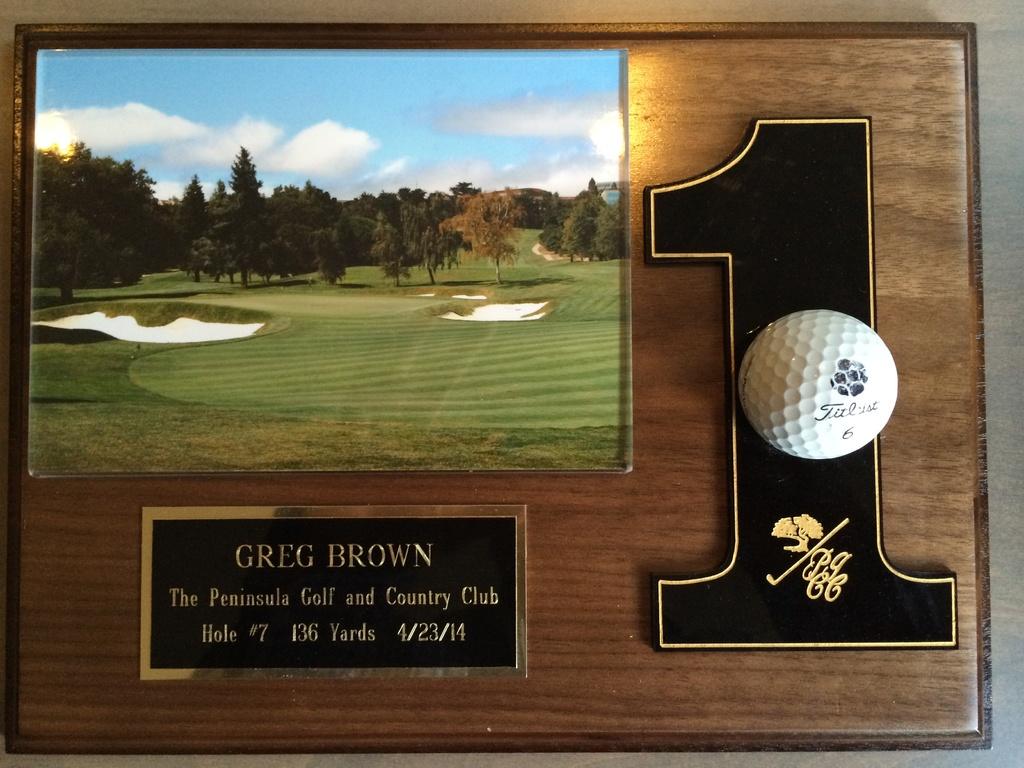What is the name on the plaque?
Keep it short and to the point. Greg brown. What number is on the right?
Give a very brief answer. 1. 